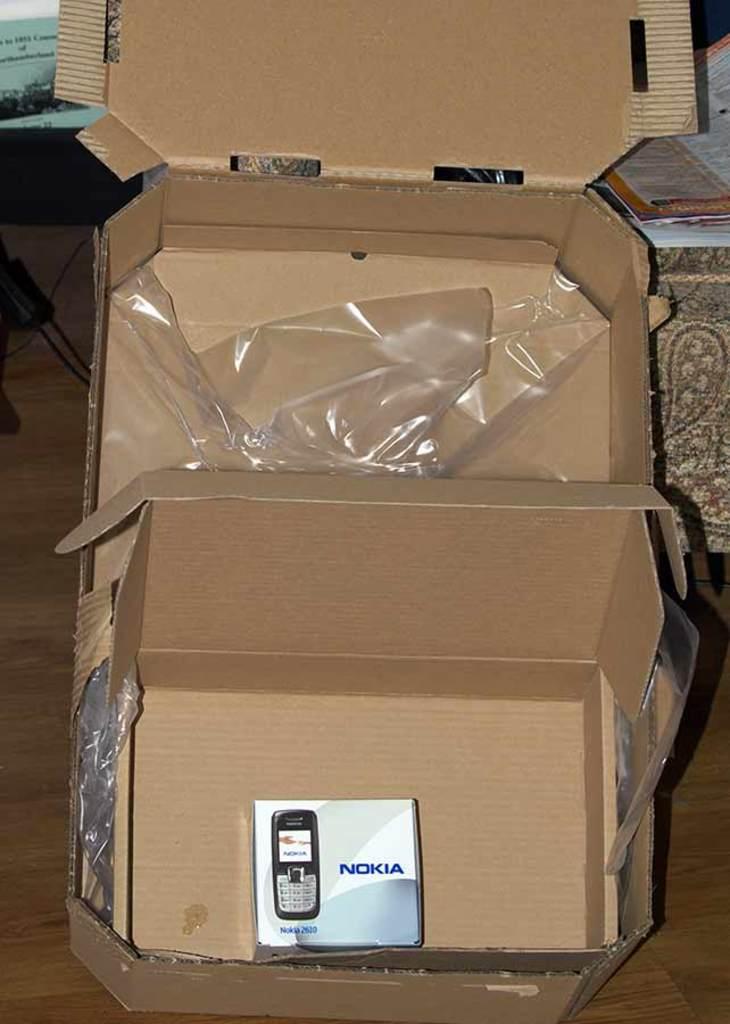Please provide a concise description of this image. In this image I can see the cardboard box and the box is in brown color. Background I can see few papers on the brown color surface. 